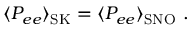<formula> <loc_0><loc_0><loc_500><loc_500>\langle P _ { e e } \rangle _ { S K } = \langle P _ { e e } \rangle _ { S N O } .</formula> 